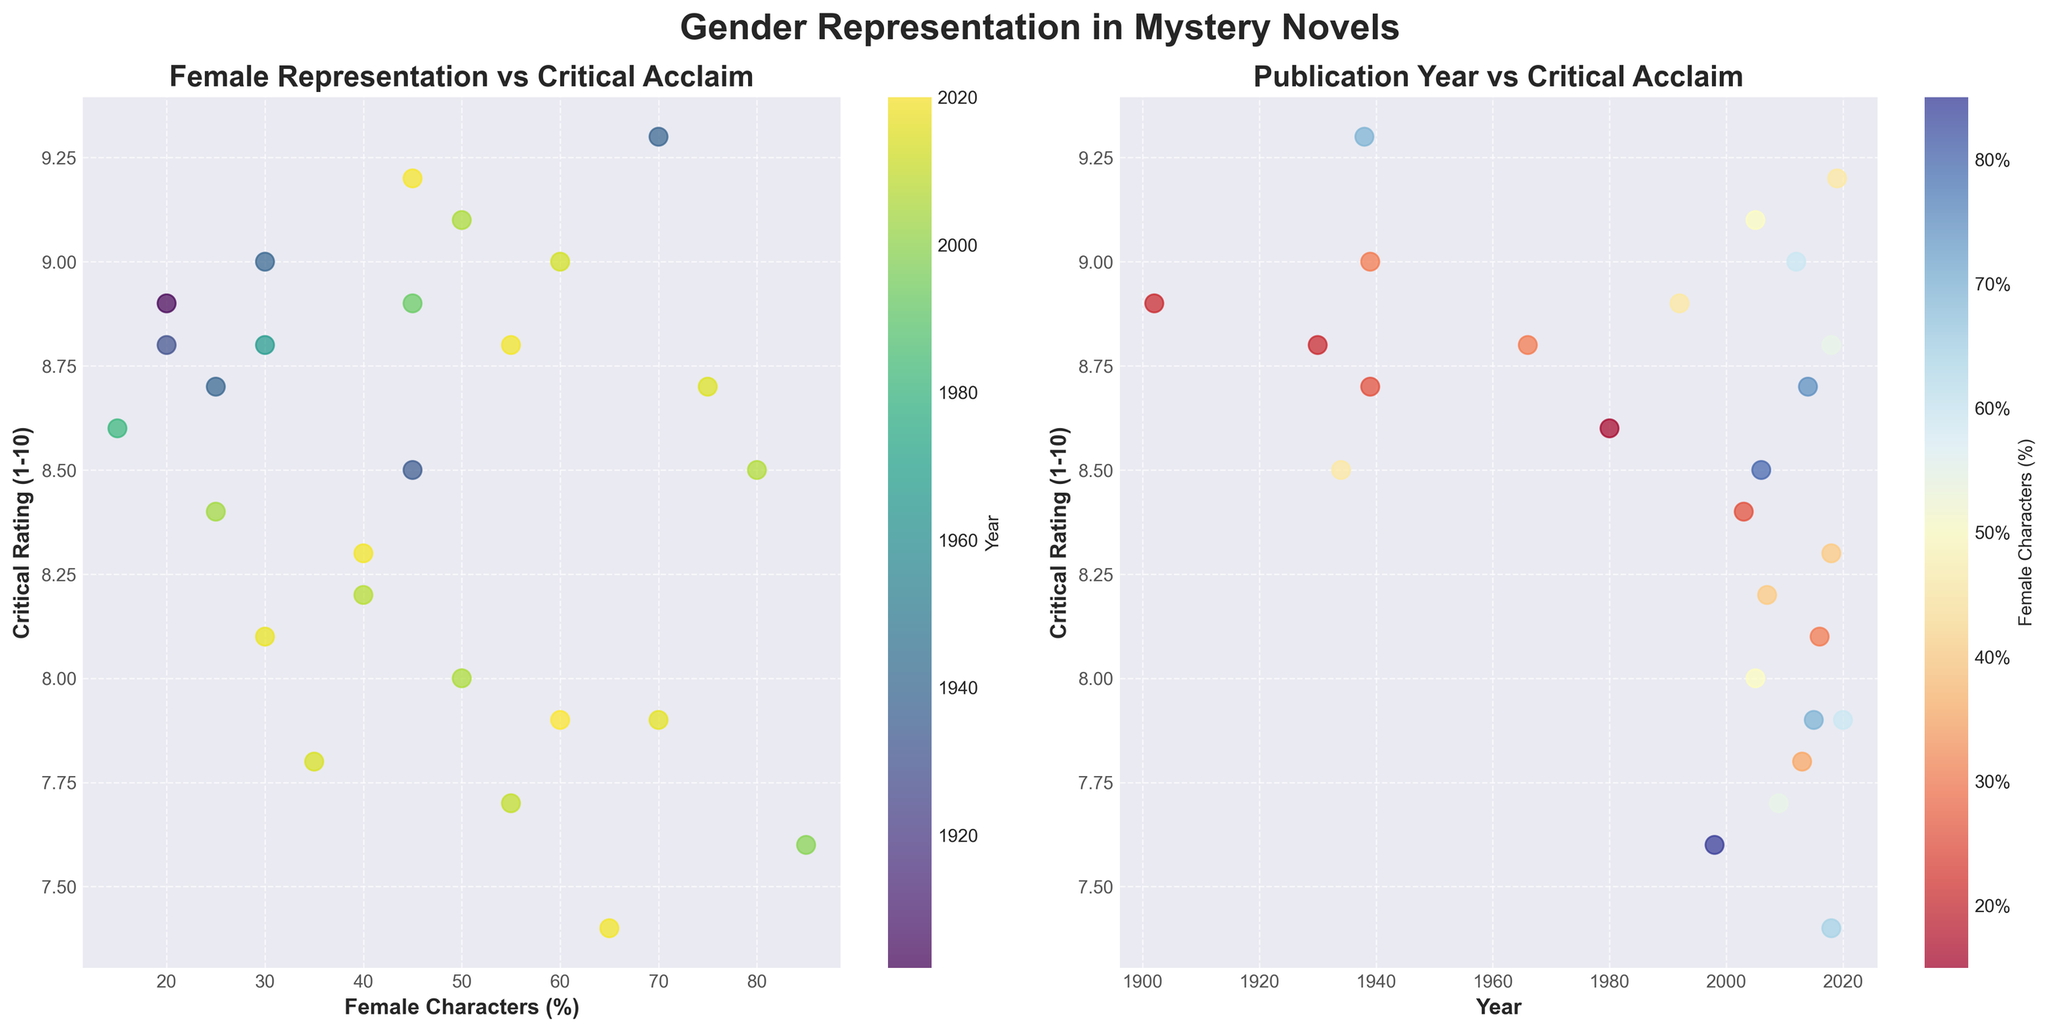What is the critical rating for titles with 70% female characters in the plot "Publication Year vs Critical Acclaim" plot? In the "Publication Year vs Critical Acclaim" plot, we notice that the points with colors indicating around 70% are blue. Locate the Year (X-axis) markers corresponding to these points. There are two titles with 70% female characters: one has a critical rating just under 8 (The Girl on the Train, rating = 7.9) and the other over 9 (Rebecca, rating = 9.3).
Answer: 7.9 and 9.3 How does the critical rating of "The Silent Patient" compare to "Where the Crawdads Sing"? Locate the points corresponding to "The Silent Patient" and "Where the Crawdads Sing" in either plot. The "Year vs Critical Acclaim" plot shows the critical ratings on the Y-axis, allowing a direct comparison. "The Silent Patient" has a rating of 9.2, whereas "Where the Crawdads Sing" has 8.8.
Answer: The Silent Patient has a higher rating Which title has the highest critical rating among those published in 2018? In the "Publication Year vs Critical Acclaim" plot, find the data points where the Year is 2018. There are three titles from 2018: "Where the Crawdads Sing" (8.8), "The Woman in the Window" (7.4), and "The 7½ Deaths of Evelyn Hardcastle" (8.3). Compare their critical ratings.
Answer: Where the Crawdads Sing What is the average critical rating for titles with more than 60% female characters? From the "Female Representation vs Critical Acclaim" plot, identify titles with more than 60% female characters, then calculate the average of their critical ratings: "Big Little Lies" (8.7), "The Woman in the Window" (7.4), "The Girl on the Train" (7.9), "Sharp Objects" (8.5), "Rebecca" (9.3), and "The No. 1 Ladies' Detective Agency" (7.6). The average is calculated as (8.7 + 7.4 + 7.9 + 8.5 + 9.3 + 7.6) / 6 = 8.23.
Answer: 8.23 What is the median critical rating for novels published before 1950? Identify data points in the "Publication Year vs Critical Acclaim" plot representing titles published before 1950. List their critical ratings: "The Maltese Falcon" (8.8), "Rebecca" (9.3), "And Then There Were None" (9.0), "The Big Sleep" (8.7), "Murder on the Orient Express" (8.5), "The Hound of the Baskervilles" (8.9). The median is identified after sorting (8.5, 8.7, 8.8, 8.9, 9.0, 9.3). The median rating is the average of the two middle values (8.8 and 8.9), which is (8.8 + 8.9) / 2 = 8.85.
Answer: 8.85 